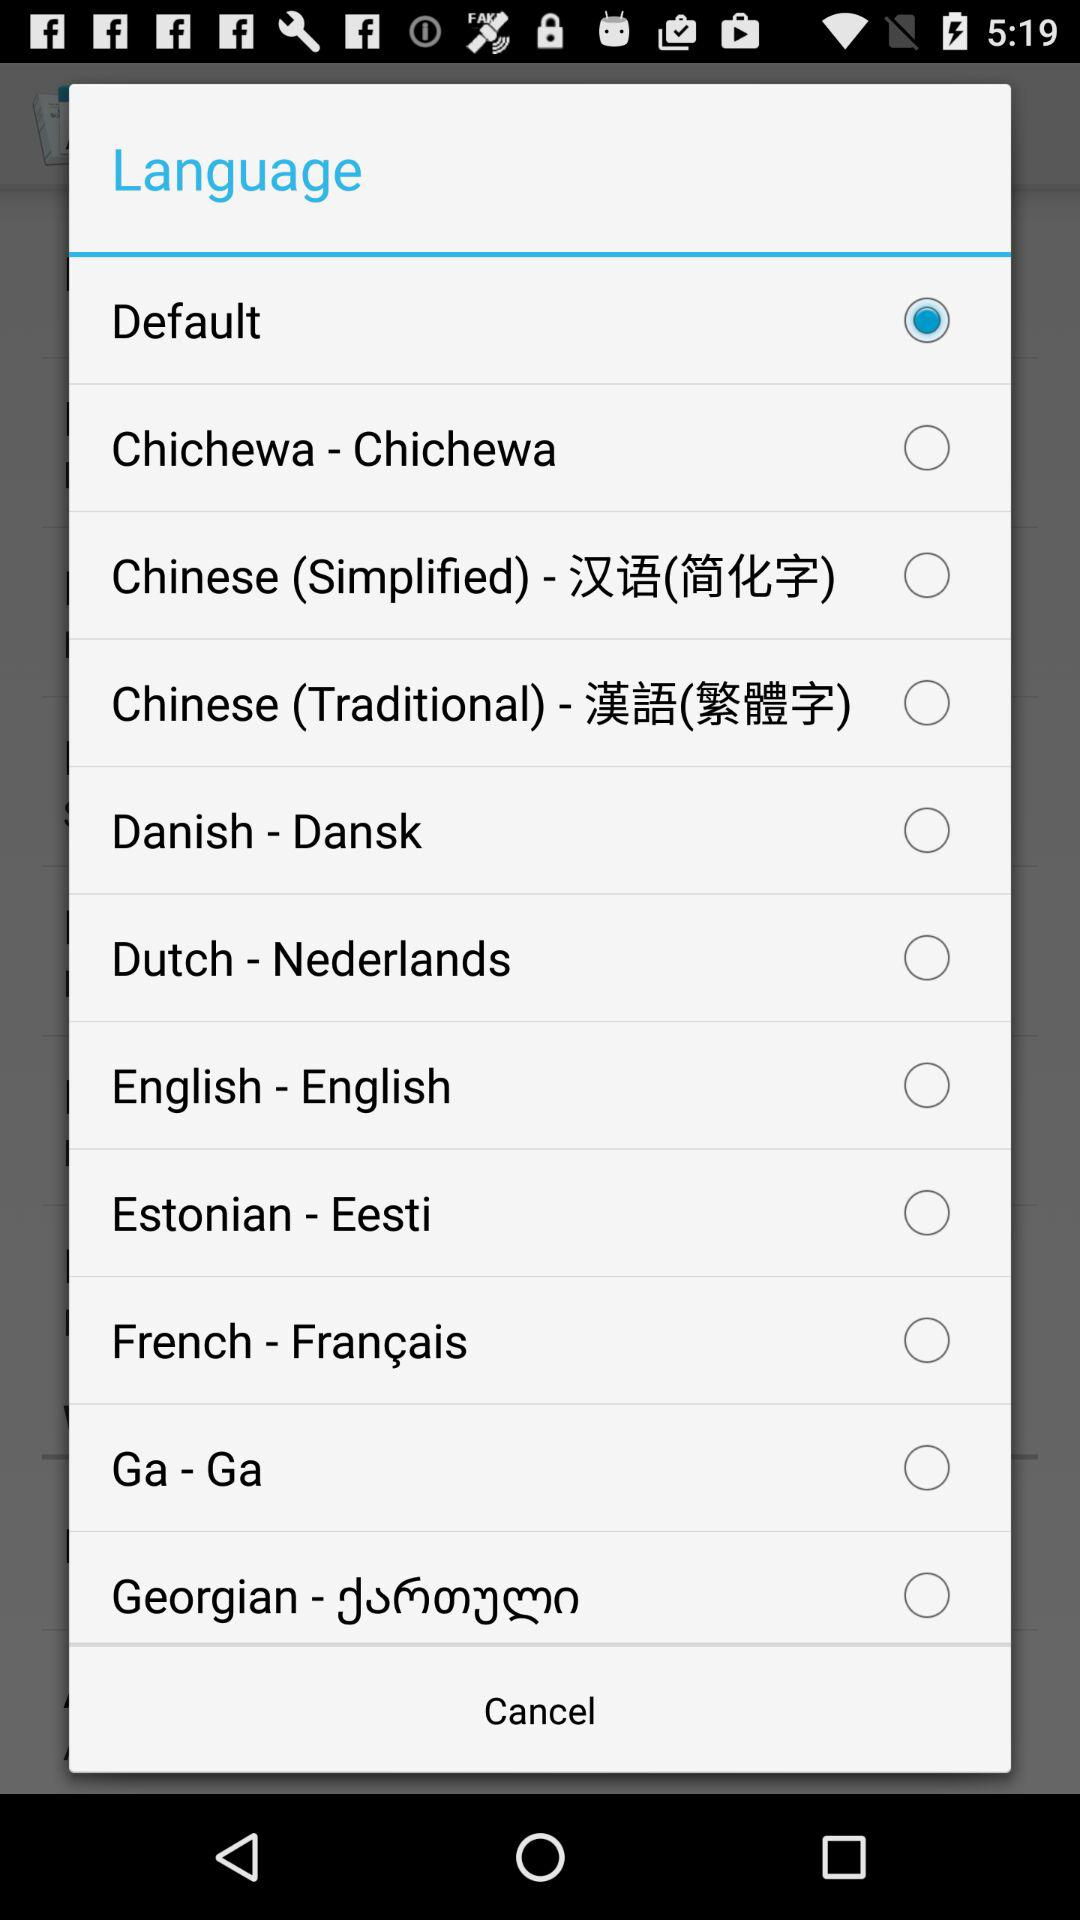How many languages are available to select?
Answer the question using a single word or phrase. 10 